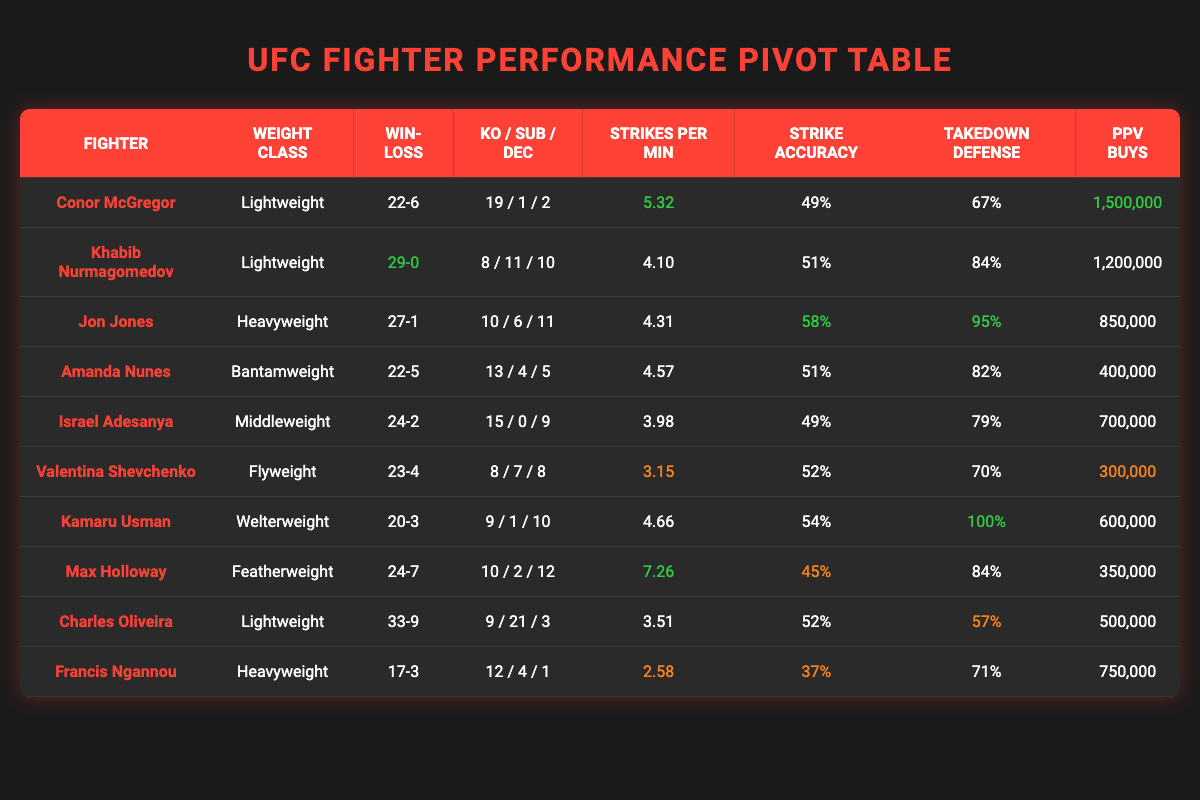What is Conor McGregor's win-loss record? The table shows Conor McGregor's record listed under "Win-Loss," which is 22-6.
Answer: 22-6 Which fighter has the highest number of knockouts? By looking at the "KO" column for all fighters, Conor McGregor has 19 knockouts, which is the highest among all fighters listed.
Answer: Conor McGregor How many fighters in the table have a perfect win record? Khabib Nurmagomedov is the only fighter that has a perfect win record listed as 29-0 in the "Win-Loss" column.
Answer: One fighter What is the average number of strikes landed per minute for the fighters in the Lightweight class? The fighters in the Lightweight class are Conor McGregor (5.32), Khabib Nurmagomedov (4.10), and Charles Oliveira (3.51). The average is calculated as (5.32 + 4.10 + 3.51) / 3 = 4.31.
Answer: 4.31 Is Amanda Nunes' strike accuracy higher than Kamaru Usman's? Amanda Nunes has a strike accuracy of 51%, while Kamaru Usman's is 54%. Since 51% is less than 54%, the statement is false.
Answer: No Which weight class has the fighter with the most PPV buys? The fighter with the most PPV buys is Conor McGregor with 1,500,000 buys, who is in the Lightweight class. This indicates that the Lightweight class has the fighter with the highest PPV buys.
Answer: Lightweight What is the total number of decision wins for all fighters in the table? To find the total, we add the decision wins: 2 (McGregor) + 10 (Nurmagomedov) + 11 (Jones) + 5 (Nunes) + 9 (Adesanya) + 8 (Shevchenko) + 10 (Usman) + 12 (Holloway) + 3 (Oliveira) + 1 (Ngannou) = 71.
Answer: 71 How many fighters have a takedown defense of more than 80%? Checking the "Takedown Defense" column, we find that Khabib Nurmagomedov, Jon Jones, Kamaru Usman, and Max Holloway have above 80%, totaling four fighters.
Answer: Four fighters Who has the lowest strike accuracy in the table? By examining the "Strike Accuracy" column, Francis Ngannou has the lowest accuracy at 37%.
Answer: Francis Ngannou 